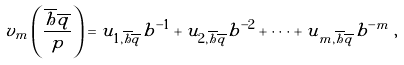<formula> <loc_0><loc_0><loc_500><loc_500>v _ { m } \left ( \frac { \overline { h } \overline { q } } { p } \right ) = u _ { 1 , \overline { h } \overline { q } } b ^ { - 1 } + u _ { 2 , \overline { h } \overline { q } } b ^ { - 2 } + \dots + u _ { m , \overline { h } \overline { q } } b ^ { - m } \, ,</formula> 